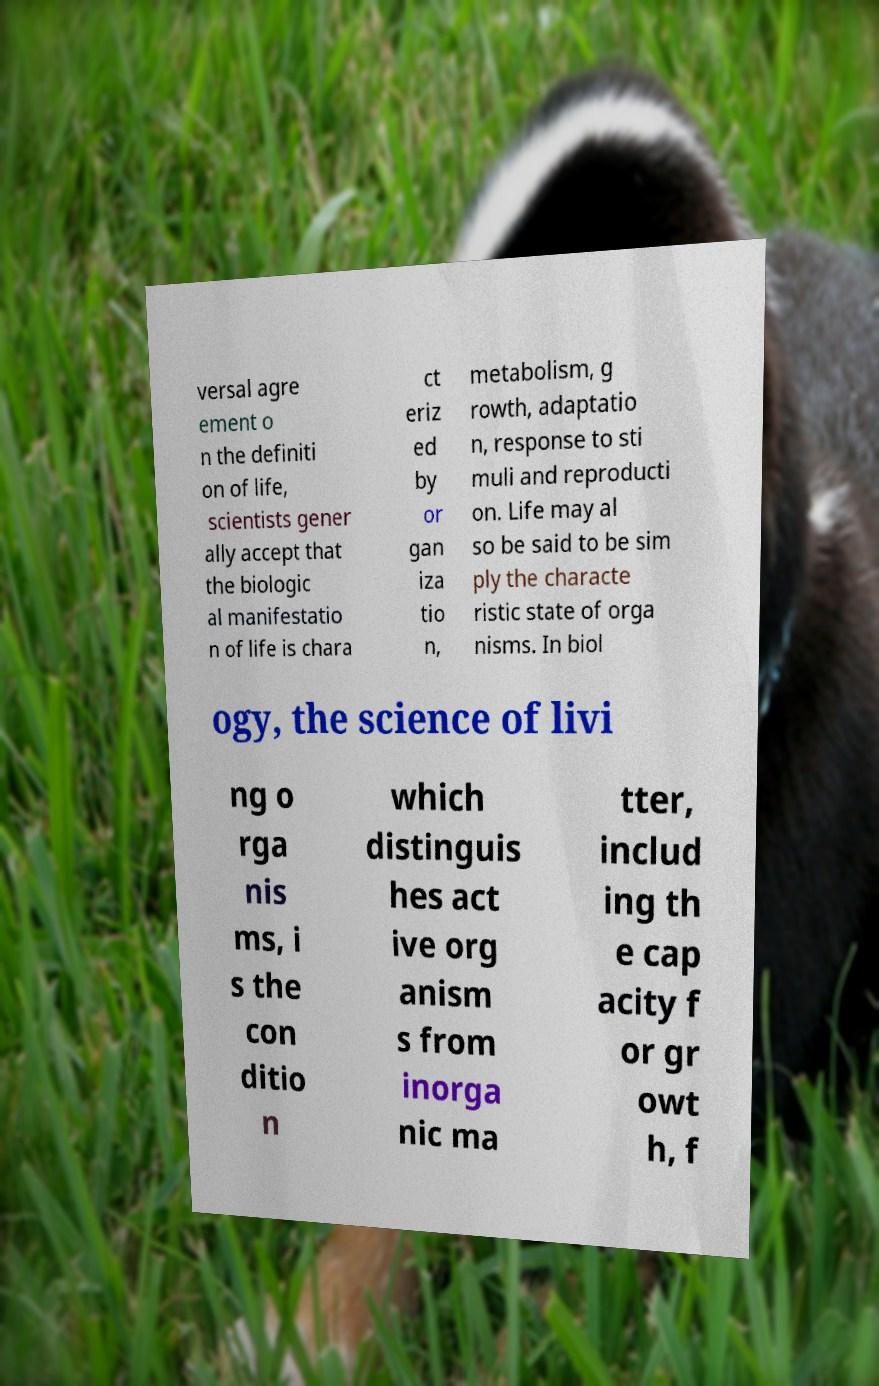Can you read and provide the text displayed in the image?This photo seems to have some interesting text. Can you extract and type it out for me? versal agre ement o n the definiti on of life, scientists gener ally accept that the biologic al manifestatio n of life is chara ct eriz ed by or gan iza tio n, metabolism, g rowth, adaptatio n, response to sti muli and reproducti on. Life may al so be said to be sim ply the characte ristic state of orga nisms. In biol ogy, the science of livi ng o rga nis ms, i s the con ditio n which distinguis hes act ive org anism s from inorga nic ma tter, includ ing th e cap acity f or gr owt h, f 